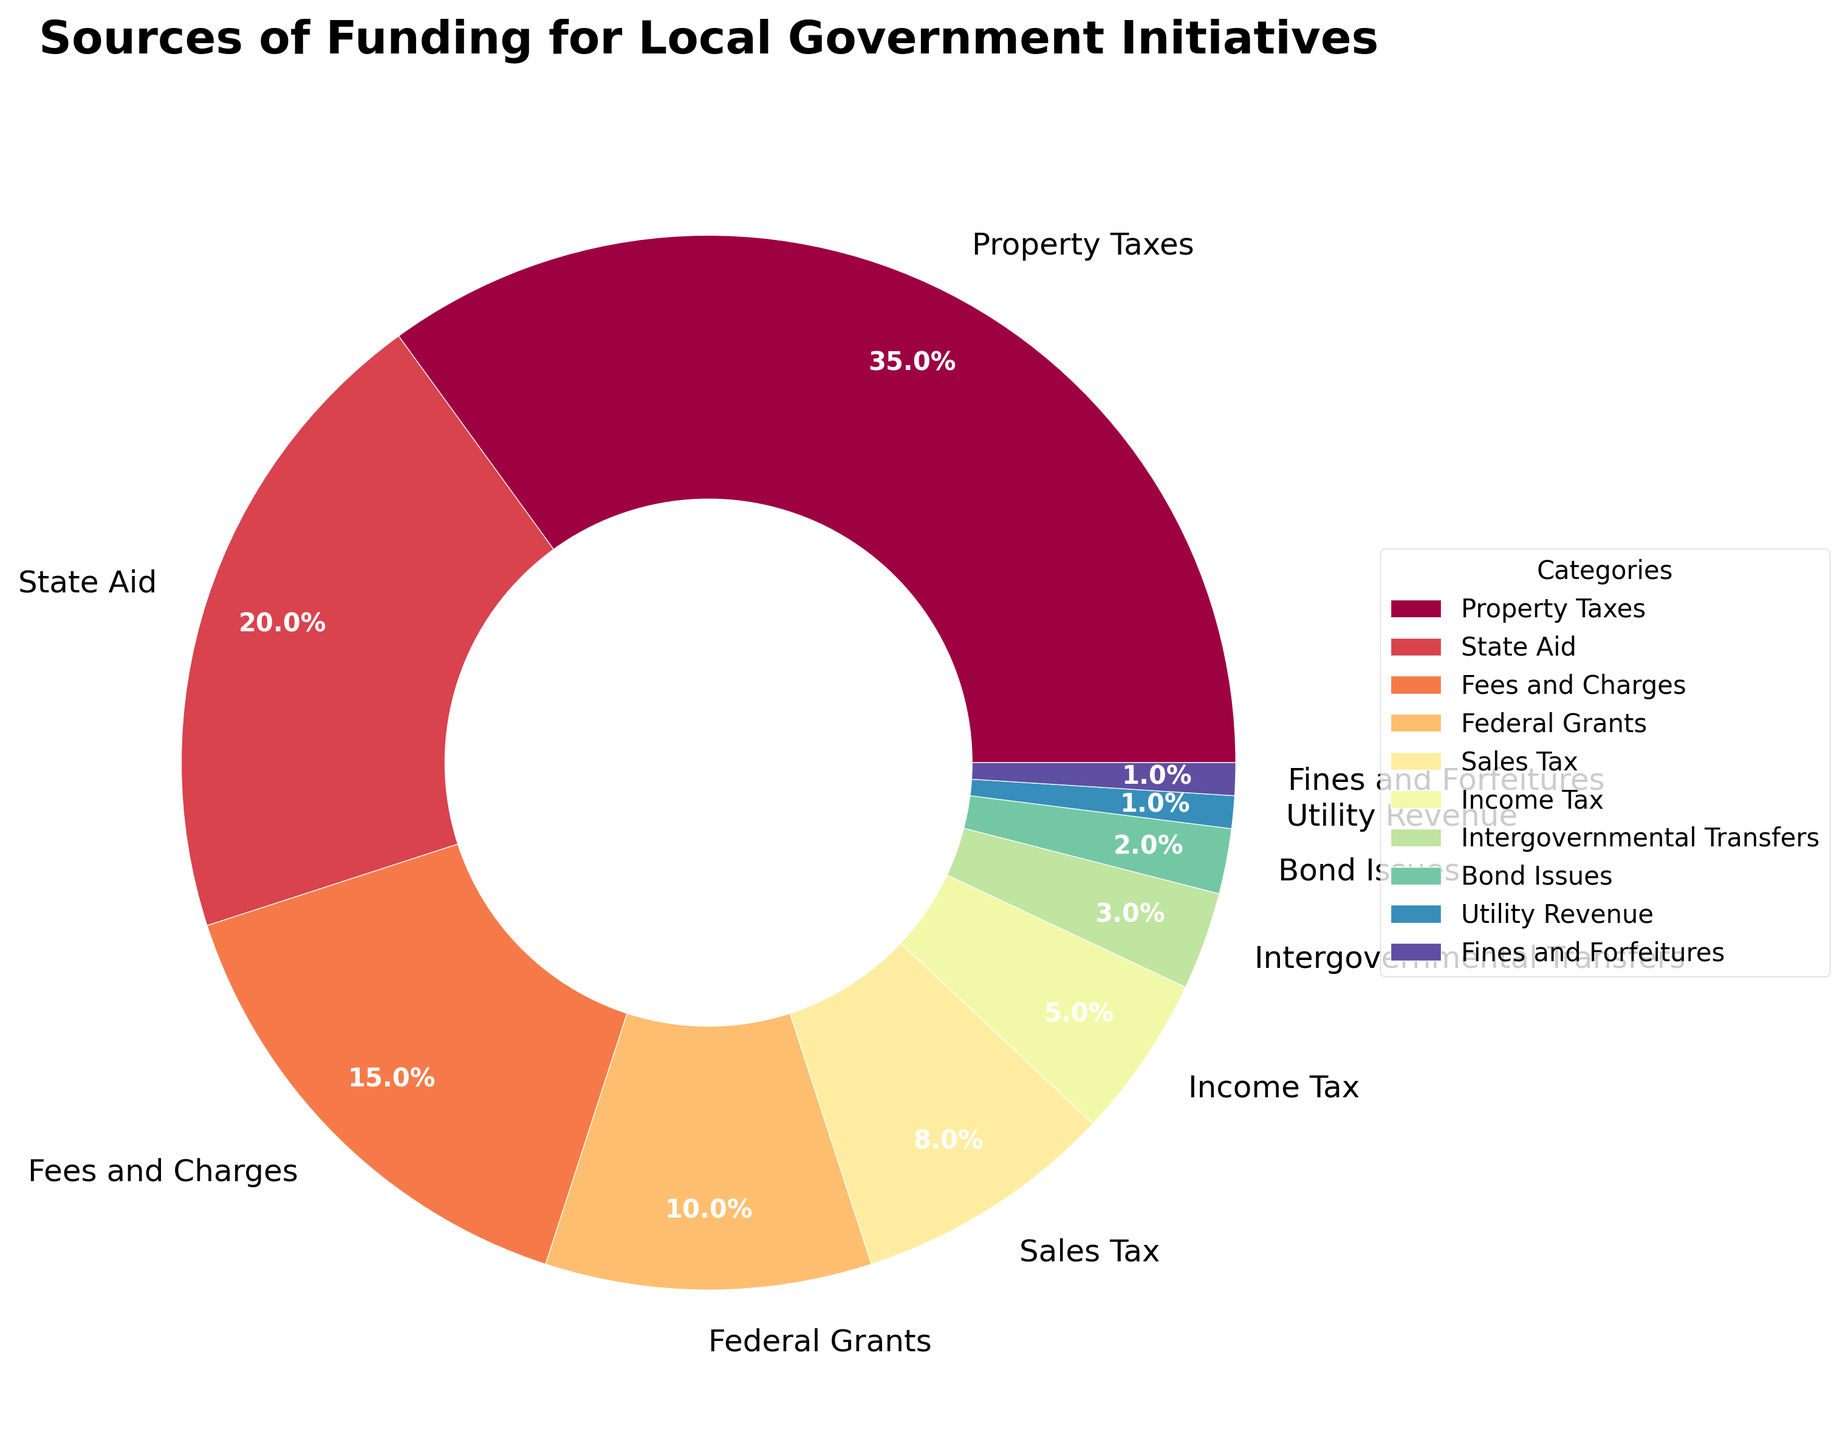What is the largest source of funding for local government initiatives? The pie chart shows that the segment representing Property Taxes is the largest, with a percentage of 35%.
Answer: Property Taxes Which source of funding contributes a higher percentage, State Aid or Federal Grants? By comparing the percentages given in the pie chart, State Aid contributes 20%, which is higher than the Federal Grants' 10%.
Answer: State Aid What is the combined percentage of Sales Tax and Income Tax? Adding the percentages from the pie chart, Sales Tax is 8% and Income Tax is 5%. Therefore, the combined percentage is 8% + 5% = 13%.
Answer: 13% How much more does Fees and Charges contribute compared to Fines and Forfeitures? According to the pie chart, Fees and Charges contribute 15% and Fines and Forfeitures contribute 1%. The difference is 15% - 1% = 14%.
Answer: 14% Which sources of funding contribute less than 5% each? From the pie chart, the sources contributing less than 5% are Intergovernmental Transfers (3%), Bond Issues (2%), Utility Revenue (1%), and Fines and Forfeitures (1%).
Answer: Intergovernmental Transfers, Bond Issues, Utility Revenue, Fines and Forfeitures Which funding source has a similar contribution to Utility Revenue? Visual inspection of the pie chart shows that Utility Revenue and Fines and Forfeitures both contribute 1% each, making them similar.
Answer: Fines and Forfeitures Is the contribution of Property Taxes more than double that of State Aid? Property Taxes contribute 35% and State Aid contributes 20%. Double of State Aid's contribution is 20% * 2 = 40%. Since 35% < 40%, the contribution of Property Taxes is not more than double that of State Aid.
Answer: No What is the difference in percentage between the highest and lowest sources of funding? The highest source is Property Taxes at 35% and the lowest sources are Utility Revenue and Fines and Forfeitures at 1% each. The difference is 35% - 1% = 34%.
Answer: 34% Which three sources together make up about half of the total funding? Adding the top three sources from the pie chart: Property Taxes (35%), State Aid (20%), and Fees and Charges (15%) gives us 35% + 20% + 15% = 70%. Adding Property Taxes (35%), State Aid (20%), and Federal Grants (10%) gives us 35% + 20% + 10% = 65%. Since both combinations are more than half, the next closest combination is Property Taxes (35%), State Aid (20%), and Sales Tax (8%) giving us 35% + 20% + 8% = 63%. Therefore, Property Taxes, State Aid, and some of a smaller source like Federal Grants, perhaps Bond Issues do contribute close but not exactly 50% of the total funding. A pair from each combination can achieve an approximately closer to half (Property Taxes + State Aid).
Answer: Property Taxes, State Aid, and some small contributions 